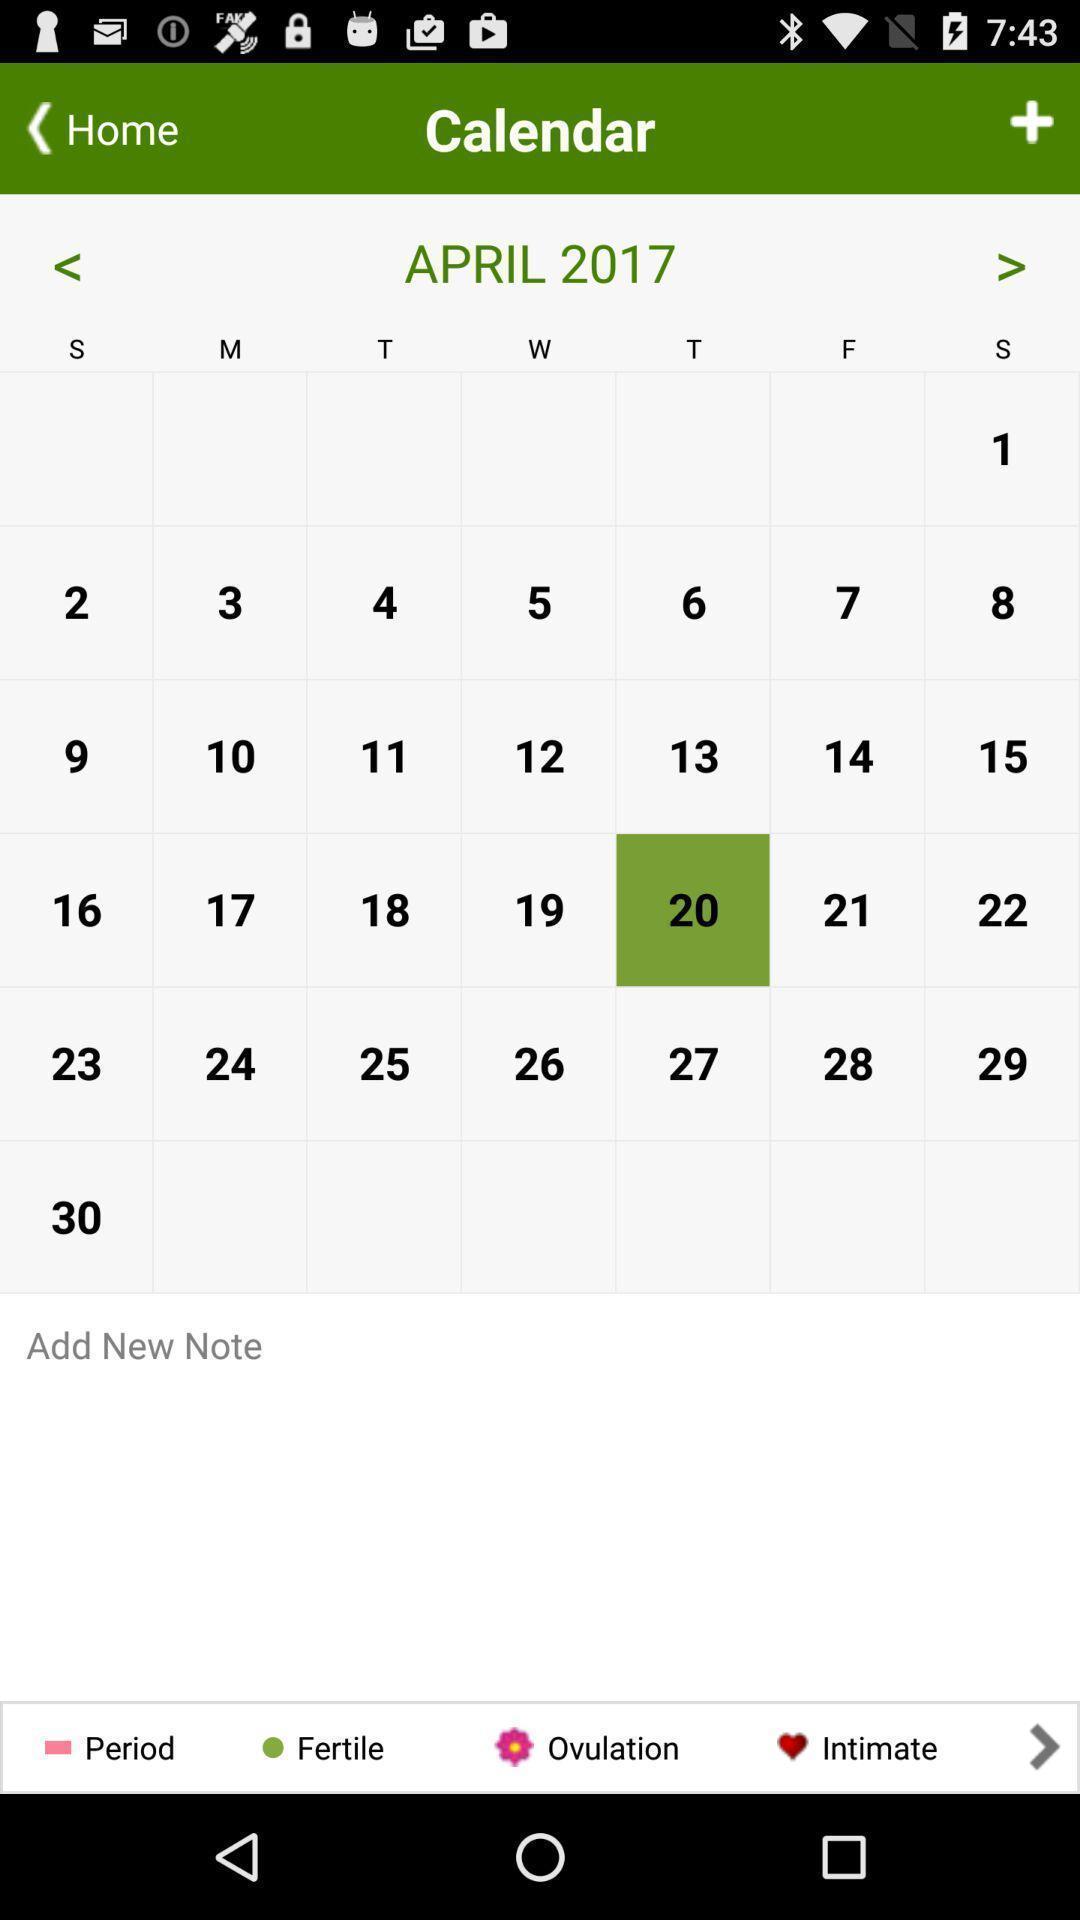What is the overall content of this screenshot? Screen shows calendar with option to add note. 